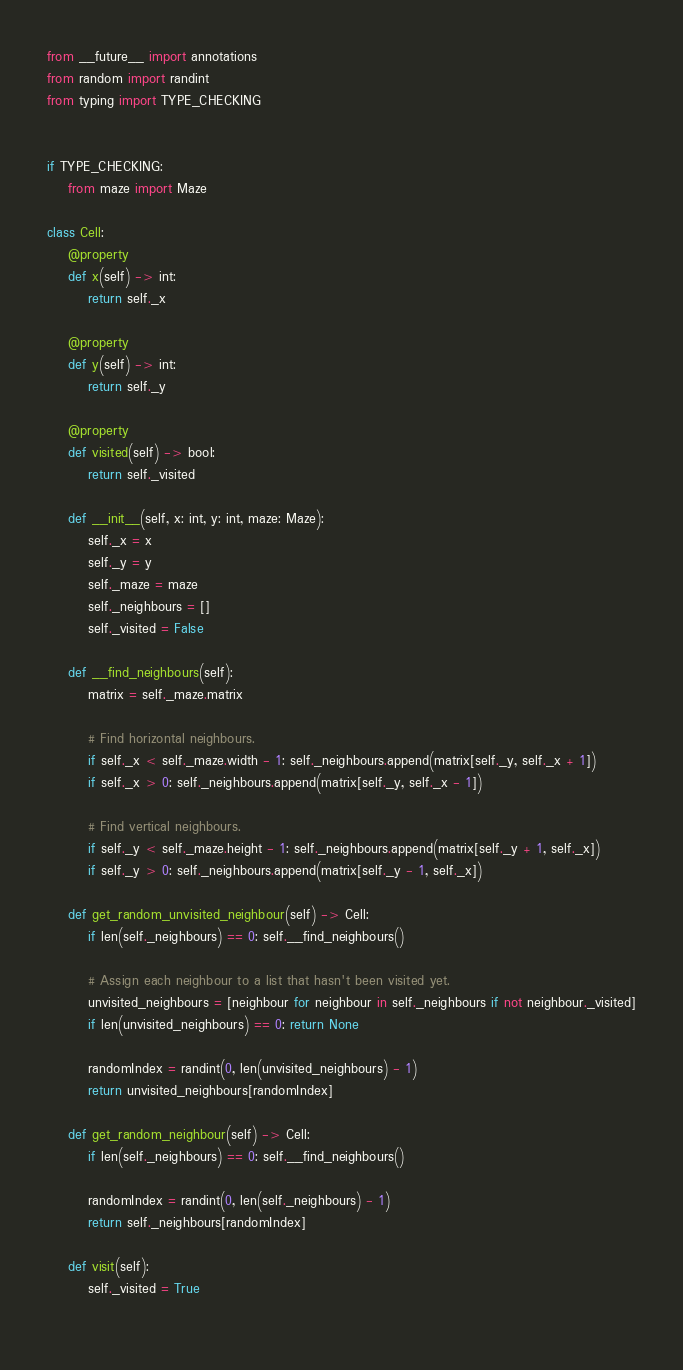<code> <loc_0><loc_0><loc_500><loc_500><_Python_>from __future__ import annotations
from random import randint
from typing import TYPE_CHECKING


if TYPE_CHECKING:
    from maze import Maze

class Cell:
    @property
    def x(self) -> int:
        return self._x
    
    @property
    def y(self) -> int:
        return self._y

    @property
    def visited(self) -> bool:
        return self._visited

    def __init__(self, x: int, y: int, maze: Maze):
        self._x = x
        self._y = y
        self._maze = maze
        self._neighbours = []
        self._visited = False

    def __find_neighbours(self):
        matrix = self._maze.matrix

        # Find horizontal neighbours.
        if self._x < self._maze.width - 1: self._neighbours.append(matrix[self._y, self._x + 1])
        if self._x > 0: self._neighbours.append(matrix[self._y, self._x - 1])
        
        # Find vertical neighbours.
        if self._y < self._maze.height - 1: self._neighbours.append(matrix[self._y + 1, self._x])
        if self._y > 0: self._neighbours.append(matrix[self._y - 1, self._x])

    def get_random_unvisited_neighbour(self) -> Cell:
        if len(self._neighbours) == 0: self.__find_neighbours()

        # Assign each neighbour to a list that hasn't been visited yet.
        unvisited_neighbours = [neighbour for neighbour in self._neighbours if not neighbour._visited]
        if len(unvisited_neighbours) == 0: return None

        randomIndex = randint(0, len(unvisited_neighbours) - 1)
        return unvisited_neighbours[randomIndex]

    def get_random_neighbour(self) -> Cell:
        if len(self._neighbours) == 0: self.__find_neighbours()
        
        randomIndex = randint(0, len(self._neighbours) - 1)
        return self._neighbours[randomIndex]

    def visit(self):
        self._visited = True
    </code> 